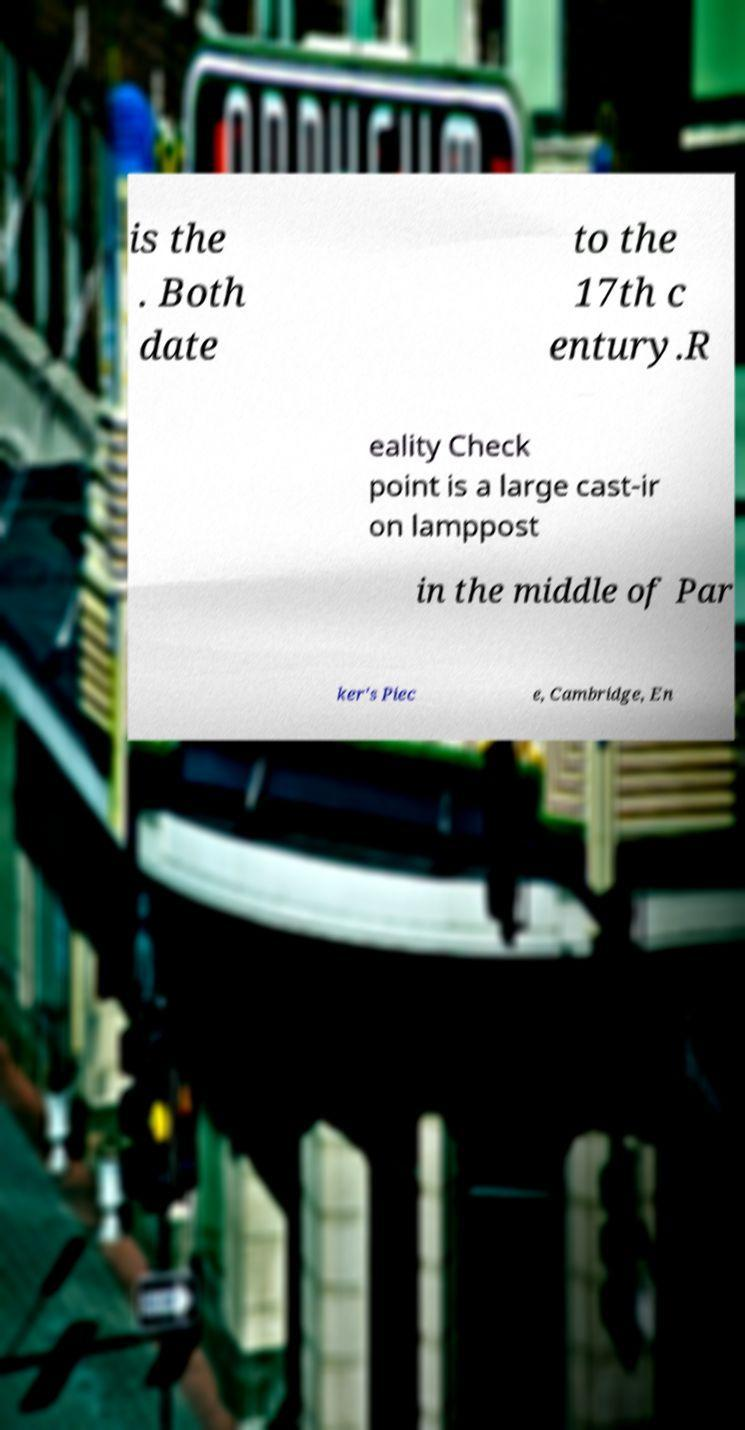Please identify and transcribe the text found in this image. is the . Both date to the 17th c entury.R eality Check point is a large cast-ir on lamppost in the middle of Par ker's Piec e, Cambridge, En 